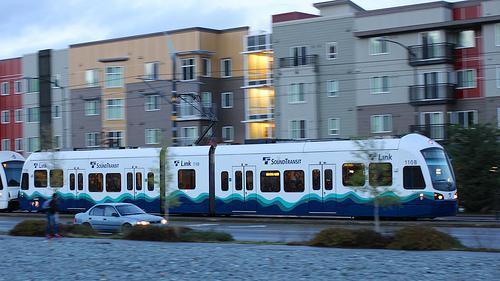How many stories are these buildings?
Give a very brief answer. 4. How many trains are there?
Give a very brief answer. 1. 